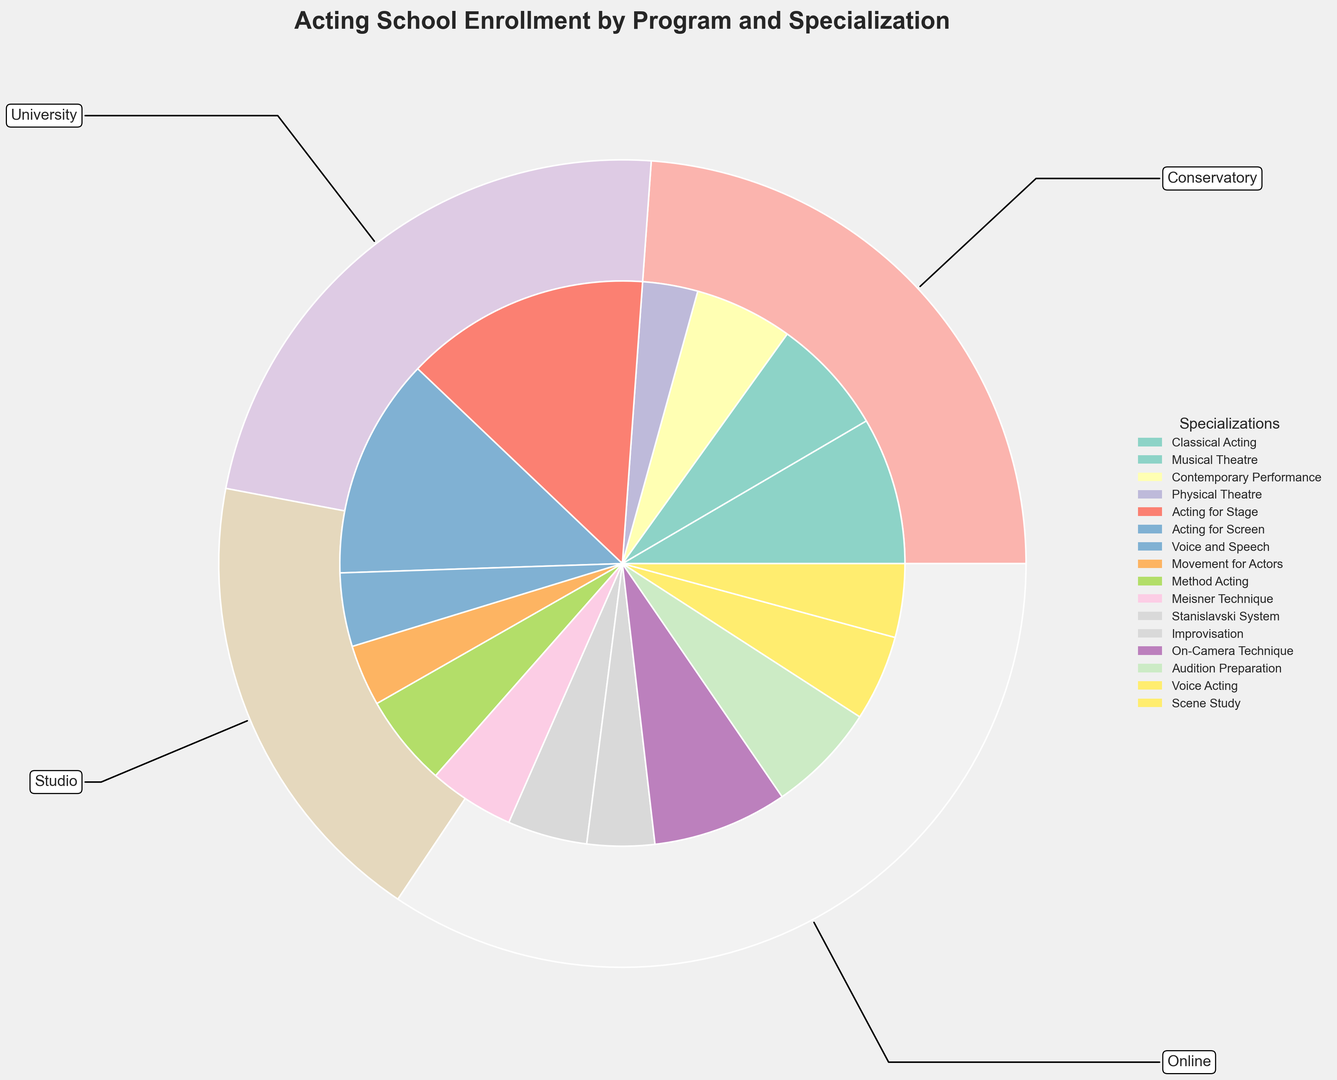What is the total enrollment for Conservatory programs? The total enrollment for Conservatory programs can be determined by summing the enrollments for each specialization within the Conservatory program. These values are 1200 (Classical Acting), 950 (Musical Theatre), 800 (Contemporary Performance), and 450 (Physical Theatre). So, 1200 + 950 + 800 + 450 = 3400.
Answer: 3400 Which program has the highest total enrollment? To find the program with the highest total enrollment, we compare the summed enrollments for each program. The University program has the highest total enrollment with values: 2000 (Acting for Stage), 1800 (Acting for Screen), 600 (Voice and Speech), and 500 (Movement for Actors), making a total of 4900.
Answer: University Compare the enrollment of the Online courses in Audition Preparation and Voice Acting. Which one is higher? The enrollment for Online Audition Preparation is 900 while for Online Voice Acting it is 700. Comparatively, Audition Preparation has a higher enrollment.
Answer: Audition Preparation Which specialization in Studio programs has the least enrollment? Checking the enrollments for specializations within Studio programs: Method Acting (750), Meisner Technique (700), Stanislavski System (650), and Improvisation (550), the specialization with the least enrollment is Improvisation.
Answer: Improvisation What is the combined enrollment for Acting for Screen and Acting for Stage in University programs? The combined enrollment for Acting for Stage and Acting for Screen in University is found by adding 2000 (Acting for Stage) and 1800 (Acting for Screen). So, 2000 + 1800 = 3800.
Answer: 3800 Which color segment represents the Method Acting specialization in the inner pie chart? To identify Method Acting, we look for the color associated with the label "Method Acting" in the legend. It matches one of the inner pie chart segments, determined visually.
Answer: [Color name based on given chart] 